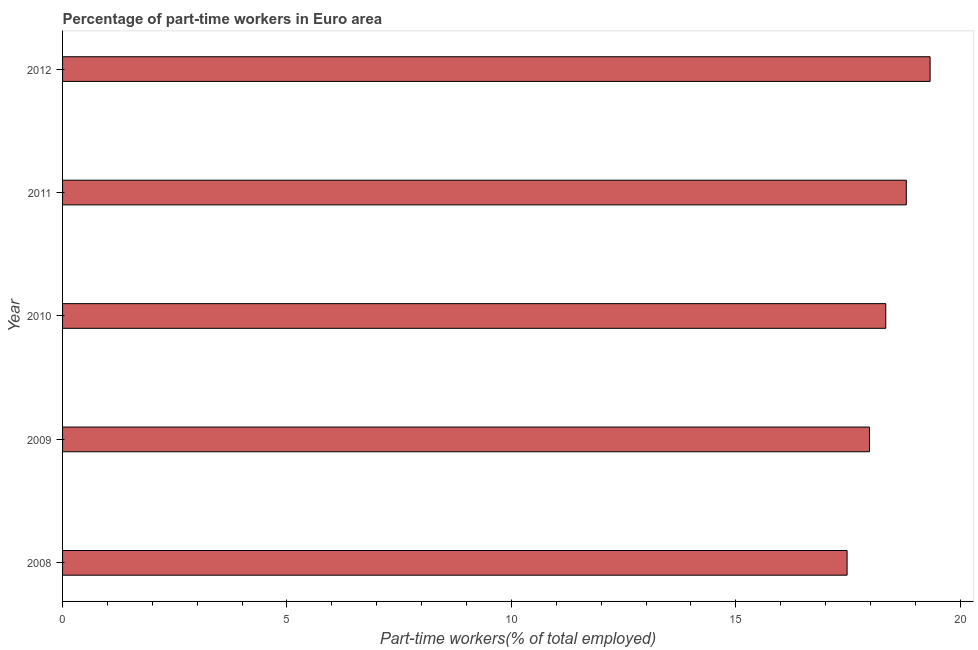Does the graph contain any zero values?
Offer a very short reply. No. Does the graph contain grids?
Your answer should be compact. No. What is the title of the graph?
Your answer should be compact. Percentage of part-time workers in Euro area. What is the label or title of the X-axis?
Your answer should be compact. Part-time workers(% of total employed). What is the percentage of part-time workers in 2012?
Offer a very short reply. 19.33. Across all years, what is the maximum percentage of part-time workers?
Keep it short and to the point. 19.33. Across all years, what is the minimum percentage of part-time workers?
Your response must be concise. 17.48. What is the sum of the percentage of part-time workers?
Your answer should be compact. 91.93. What is the difference between the percentage of part-time workers in 2008 and 2011?
Your answer should be compact. -1.32. What is the average percentage of part-time workers per year?
Provide a short and direct response. 18.39. What is the median percentage of part-time workers?
Offer a very short reply. 18.34. In how many years, is the percentage of part-time workers greater than 9 %?
Give a very brief answer. 5. Do a majority of the years between 2008 and 2010 (inclusive) have percentage of part-time workers greater than 15 %?
Your answer should be compact. Yes. What is the ratio of the percentage of part-time workers in 2009 to that in 2010?
Provide a short and direct response. 0.98. Is the percentage of part-time workers in 2008 less than that in 2010?
Ensure brevity in your answer.  Yes. What is the difference between the highest and the second highest percentage of part-time workers?
Ensure brevity in your answer.  0.53. Is the sum of the percentage of part-time workers in 2010 and 2012 greater than the maximum percentage of part-time workers across all years?
Offer a very short reply. Yes. What is the difference between the highest and the lowest percentage of part-time workers?
Give a very brief answer. 1.85. In how many years, is the percentage of part-time workers greater than the average percentage of part-time workers taken over all years?
Keep it short and to the point. 2. How many bars are there?
Your answer should be very brief. 5. Are all the bars in the graph horizontal?
Make the answer very short. Yes. Are the values on the major ticks of X-axis written in scientific E-notation?
Your response must be concise. No. What is the Part-time workers(% of total employed) in 2008?
Offer a very short reply. 17.48. What is the Part-time workers(% of total employed) of 2009?
Offer a terse response. 17.98. What is the Part-time workers(% of total employed) in 2010?
Make the answer very short. 18.34. What is the Part-time workers(% of total employed) of 2011?
Ensure brevity in your answer.  18.8. What is the Part-time workers(% of total employed) of 2012?
Your answer should be very brief. 19.33. What is the difference between the Part-time workers(% of total employed) in 2008 and 2009?
Offer a terse response. -0.5. What is the difference between the Part-time workers(% of total employed) in 2008 and 2010?
Your answer should be very brief. -0.86. What is the difference between the Part-time workers(% of total employed) in 2008 and 2011?
Give a very brief answer. -1.32. What is the difference between the Part-time workers(% of total employed) in 2008 and 2012?
Give a very brief answer. -1.85. What is the difference between the Part-time workers(% of total employed) in 2009 and 2010?
Your answer should be very brief. -0.36. What is the difference between the Part-time workers(% of total employed) in 2009 and 2011?
Your answer should be compact. -0.82. What is the difference between the Part-time workers(% of total employed) in 2009 and 2012?
Make the answer very short. -1.35. What is the difference between the Part-time workers(% of total employed) in 2010 and 2011?
Offer a very short reply. -0.46. What is the difference between the Part-time workers(% of total employed) in 2010 and 2012?
Your response must be concise. -0.99. What is the difference between the Part-time workers(% of total employed) in 2011 and 2012?
Your response must be concise. -0.53. What is the ratio of the Part-time workers(% of total employed) in 2008 to that in 2009?
Your answer should be compact. 0.97. What is the ratio of the Part-time workers(% of total employed) in 2008 to that in 2010?
Provide a short and direct response. 0.95. What is the ratio of the Part-time workers(% of total employed) in 2008 to that in 2011?
Offer a very short reply. 0.93. What is the ratio of the Part-time workers(% of total employed) in 2008 to that in 2012?
Your answer should be compact. 0.9. What is the ratio of the Part-time workers(% of total employed) in 2009 to that in 2010?
Make the answer very short. 0.98. What is the ratio of the Part-time workers(% of total employed) in 2009 to that in 2011?
Your answer should be compact. 0.96. What is the ratio of the Part-time workers(% of total employed) in 2009 to that in 2012?
Offer a terse response. 0.93. What is the ratio of the Part-time workers(% of total employed) in 2010 to that in 2011?
Give a very brief answer. 0.98. What is the ratio of the Part-time workers(% of total employed) in 2010 to that in 2012?
Make the answer very short. 0.95. 